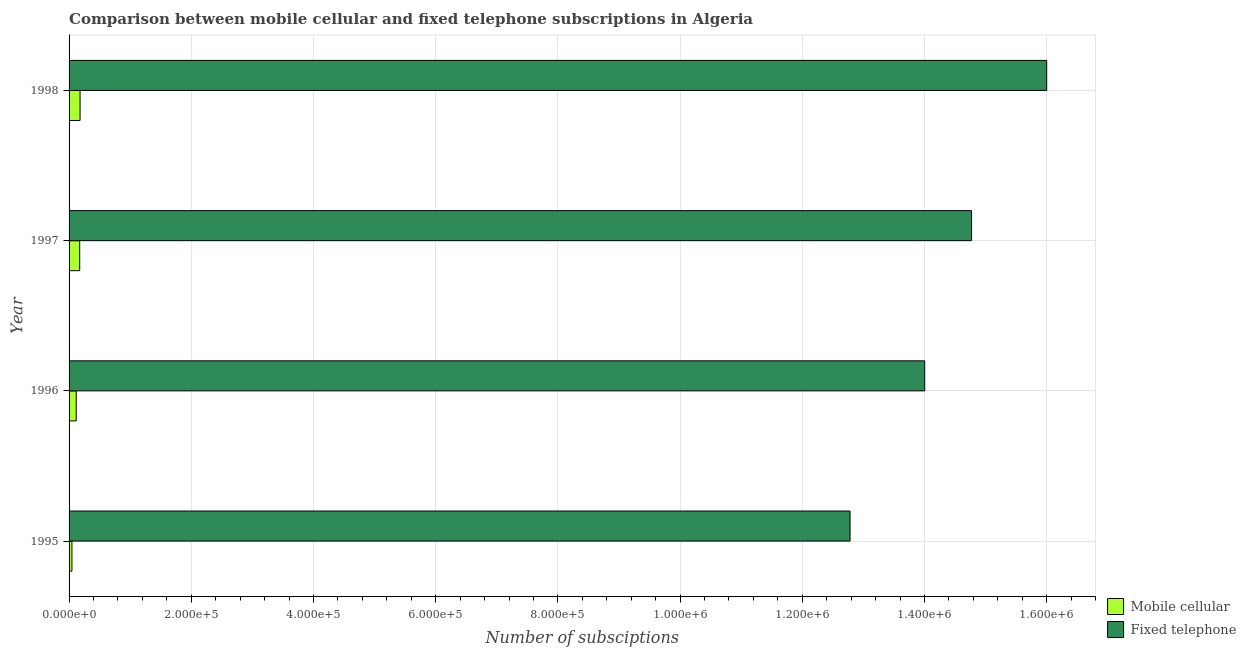How many groups of bars are there?
Ensure brevity in your answer.  4. Are the number of bars per tick equal to the number of legend labels?
Ensure brevity in your answer.  Yes. How many bars are there on the 1st tick from the top?
Offer a very short reply. 2. What is the label of the 2nd group of bars from the top?
Offer a terse response. 1997. In how many cases, is the number of bars for a given year not equal to the number of legend labels?
Provide a short and direct response. 0. What is the number of mobile cellular subscriptions in 1997?
Your answer should be compact. 1.74e+04. Across all years, what is the maximum number of mobile cellular subscriptions?
Offer a very short reply. 1.80e+04. Across all years, what is the minimum number of fixed telephone subscriptions?
Make the answer very short. 1.28e+06. In which year was the number of fixed telephone subscriptions minimum?
Keep it short and to the point. 1995. What is the total number of mobile cellular subscriptions in the graph?
Make the answer very short. 5.18e+04. What is the difference between the number of fixed telephone subscriptions in 1995 and that in 1998?
Keep it short and to the point. -3.22e+05. What is the difference between the number of mobile cellular subscriptions in 1998 and the number of fixed telephone subscriptions in 1997?
Your answer should be very brief. -1.46e+06. What is the average number of mobile cellular subscriptions per year?
Provide a short and direct response. 1.29e+04. In the year 1996, what is the difference between the number of fixed telephone subscriptions and number of mobile cellular subscriptions?
Ensure brevity in your answer.  1.39e+06. What is the ratio of the number of mobile cellular subscriptions in 1995 to that in 1998?
Provide a short and direct response. 0.26. What is the difference between the highest and the second highest number of mobile cellular subscriptions?
Give a very brief answer. 600. What is the difference between the highest and the lowest number of fixed telephone subscriptions?
Give a very brief answer. 3.22e+05. Is the sum of the number of mobile cellular subscriptions in 1996 and 1998 greater than the maximum number of fixed telephone subscriptions across all years?
Provide a succinct answer. No. What does the 1st bar from the top in 1998 represents?
Provide a short and direct response. Fixed telephone. What does the 1st bar from the bottom in 1997 represents?
Your answer should be very brief. Mobile cellular. How many bars are there?
Keep it short and to the point. 8. What is the title of the graph?
Your response must be concise. Comparison between mobile cellular and fixed telephone subscriptions in Algeria. Does "Secondary education" appear as one of the legend labels in the graph?
Offer a very short reply. No. What is the label or title of the X-axis?
Your response must be concise. Number of subsciptions. What is the Number of subsciptions of Mobile cellular in 1995?
Your answer should be compact. 4691. What is the Number of subsciptions in Fixed telephone in 1995?
Make the answer very short. 1.28e+06. What is the Number of subsciptions in Mobile cellular in 1996?
Provide a short and direct response. 1.17e+04. What is the Number of subsciptions of Fixed telephone in 1996?
Ensure brevity in your answer.  1.40e+06. What is the Number of subsciptions of Mobile cellular in 1997?
Your answer should be very brief. 1.74e+04. What is the Number of subsciptions in Fixed telephone in 1997?
Provide a short and direct response. 1.48e+06. What is the Number of subsciptions in Mobile cellular in 1998?
Keep it short and to the point. 1.80e+04. What is the Number of subsciptions of Fixed telephone in 1998?
Your response must be concise. 1.60e+06. Across all years, what is the maximum Number of subsciptions of Mobile cellular?
Your answer should be very brief. 1.80e+04. Across all years, what is the maximum Number of subsciptions in Fixed telephone?
Offer a very short reply. 1.60e+06. Across all years, what is the minimum Number of subsciptions of Mobile cellular?
Provide a succinct answer. 4691. Across all years, what is the minimum Number of subsciptions of Fixed telephone?
Ensure brevity in your answer.  1.28e+06. What is the total Number of subsciptions in Mobile cellular in the graph?
Your answer should be compact. 5.18e+04. What is the total Number of subsciptions of Fixed telephone in the graph?
Provide a short and direct response. 5.76e+06. What is the difference between the Number of subsciptions in Mobile cellular in 1995 and that in 1996?
Your answer should be very brief. -7009. What is the difference between the Number of subsciptions in Fixed telephone in 1995 and that in 1996?
Give a very brief answer. -1.22e+05. What is the difference between the Number of subsciptions of Mobile cellular in 1995 and that in 1997?
Provide a short and direct response. -1.27e+04. What is the difference between the Number of subsciptions of Fixed telephone in 1995 and that in 1997?
Your response must be concise. -1.99e+05. What is the difference between the Number of subsciptions in Mobile cellular in 1995 and that in 1998?
Your response must be concise. -1.33e+04. What is the difference between the Number of subsciptions of Fixed telephone in 1995 and that in 1998?
Ensure brevity in your answer.  -3.22e+05. What is the difference between the Number of subsciptions in Mobile cellular in 1996 and that in 1997?
Offer a terse response. -5700. What is the difference between the Number of subsciptions in Fixed telephone in 1996 and that in 1997?
Keep it short and to the point. -7.67e+04. What is the difference between the Number of subsciptions in Mobile cellular in 1996 and that in 1998?
Provide a succinct answer. -6300. What is the difference between the Number of subsciptions of Fixed telephone in 1996 and that in 1998?
Provide a succinct answer. -2.00e+05. What is the difference between the Number of subsciptions of Mobile cellular in 1997 and that in 1998?
Your answer should be very brief. -600. What is the difference between the Number of subsciptions in Fixed telephone in 1997 and that in 1998?
Provide a succinct answer. -1.23e+05. What is the difference between the Number of subsciptions of Mobile cellular in 1995 and the Number of subsciptions of Fixed telephone in 1996?
Give a very brief answer. -1.40e+06. What is the difference between the Number of subsciptions in Mobile cellular in 1995 and the Number of subsciptions in Fixed telephone in 1997?
Your response must be concise. -1.47e+06. What is the difference between the Number of subsciptions of Mobile cellular in 1995 and the Number of subsciptions of Fixed telephone in 1998?
Provide a succinct answer. -1.60e+06. What is the difference between the Number of subsciptions of Mobile cellular in 1996 and the Number of subsciptions of Fixed telephone in 1997?
Your response must be concise. -1.47e+06. What is the difference between the Number of subsciptions in Mobile cellular in 1996 and the Number of subsciptions in Fixed telephone in 1998?
Provide a succinct answer. -1.59e+06. What is the difference between the Number of subsciptions of Mobile cellular in 1997 and the Number of subsciptions of Fixed telephone in 1998?
Offer a very short reply. -1.58e+06. What is the average Number of subsciptions of Mobile cellular per year?
Provide a short and direct response. 1.29e+04. What is the average Number of subsciptions in Fixed telephone per year?
Provide a succinct answer. 1.44e+06. In the year 1995, what is the difference between the Number of subsciptions in Mobile cellular and Number of subsciptions in Fixed telephone?
Provide a succinct answer. -1.27e+06. In the year 1996, what is the difference between the Number of subsciptions of Mobile cellular and Number of subsciptions of Fixed telephone?
Your answer should be very brief. -1.39e+06. In the year 1997, what is the difference between the Number of subsciptions of Mobile cellular and Number of subsciptions of Fixed telephone?
Your response must be concise. -1.46e+06. In the year 1998, what is the difference between the Number of subsciptions in Mobile cellular and Number of subsciptions in Fixed telephone?
Offer a very short reply. -1.58e+06. What is the ratio of the Number of subsciptions in Mobile cellular in 1995 to that in 1996?
Ensure brevity in your answer.  0.4. What is the ratio of the Number of subsciptions of Fixed telephone in 1995 to that in 1996?
Your answer should be compact. 0.91. What is the ratio of the Number of subsciptions in Mobile cellular in 1995 to that in 1997?
Make the answer very short. 0.27. What is the ratio of the Number of subsciptions of Fixed telephone in 1995 to that in 1997?
Your response must be concise. 0.87. What is the ratio of the Number of subsciptions in Mobile cellular in 1995 to that in 1998?
Ensure brevity in your answer.  0.26. What is the ratio of the Number of subsciptions of Fixed telephone in 1995 to that in 1998?
Provide a succinct answer. 0.8. What is the ratio of the Number of subsciptions of Mobile cellular in 1996 to that in 1997?
Give a very brief answer. 0.67. What is the ratio of the Number of subsciptions of Fixed telephone in 1996 to that in 1997?
Your answer should be very brief. 0.95. What is the ratio of the Number of subsciptions of Mobile cellular in 1996 to that in 1998?
Keep it short and to the point. 0.65. What is the ratio of the Number of subsciptions of Fixed telephone in 1996 to that in 1998?
Offer a very short reply. 0.88. What is the ratio of the Number of subsciptions in Mobile cellular in 1997 to that in 1998?
Your response must be concise. 0.97. What is the difference between the highest and the second highest Number of subsciptions in Mobile cellular?
Keep it short and to the point. 600. What is the difference between the highest and the second highest Number of subsciptions of Fixed telephone?
Your answer should be compact. 1.23e+05. What is the difference between the highest and the lowest Number of subsciptions in Mobile cellular?
Ensure brevity in your answer.  1.33e+04. What is the difference between the highest and the lowest Number of subsciptions in Fixed telephone?
Make the answer very short. 3.22e+05. 